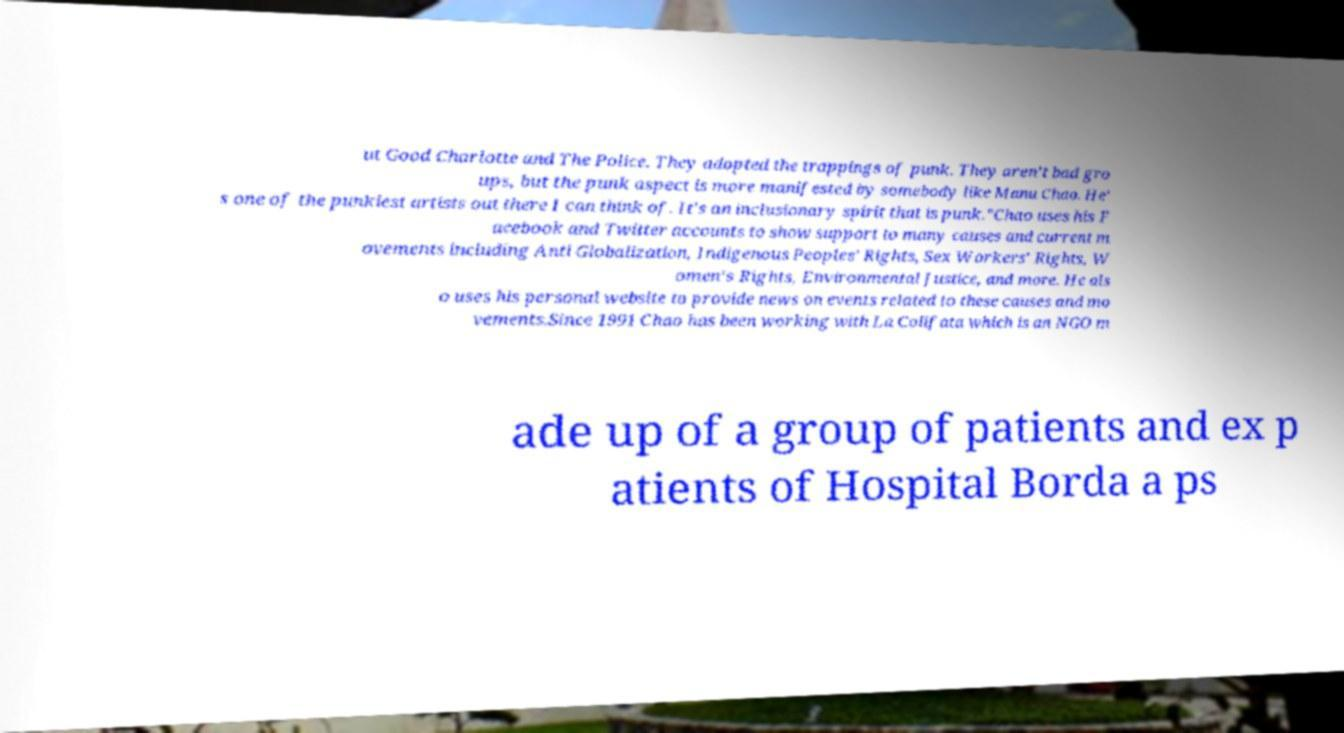Can you read and provide the text displayed in the image?This photo seems to have some interesting text. Can you extract and type it out for me? ut Good Charlotte and The Police. They adopted the trappings of punk. They aren’t bad gro ups, but the punk aspect is more manifested by somebody like Manu Chao. He' s one of the punkiest artists out there I can think of. It's an inclusionary spirit that is punk."Chao uses his F acebook and Twitter accounts to show support to many causes and current m ovements including Anti Globalization, Indigenous Peoples' Rights, Sex Workers' Rights, W omen's Rights, Environmental Justice, and more. He als o uses his personal website to provide news on events related to these causes and mo vements.Since 1991 Chao has been working with La Colifata which is an NGO m ade up of a group of patients and ex p atients of Hospital Borda a ps 